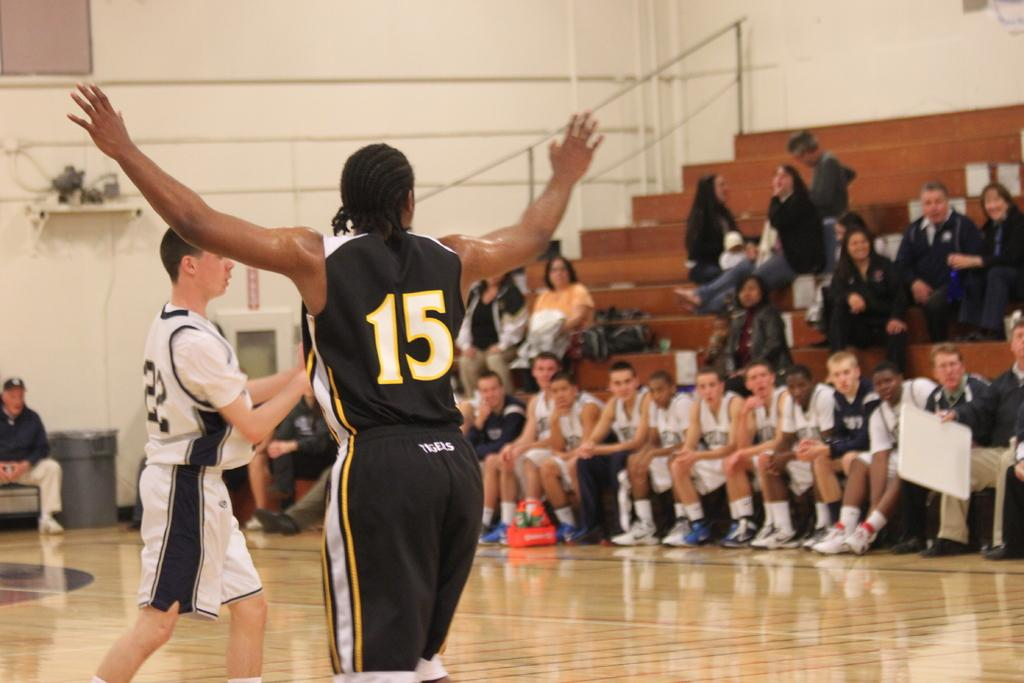What are the people in the center of the image doing? The people standing in the center of the image are likely engaged in some activity or conversation. What can be seen in the background of the image? In the background, there are people sitting on the stairs, and there is a wall. What is the surface beneath the people in the image? The bottom of the image contains a floor. What type of wheel can be seen in the image? There is no wheel present in the image. How are the people in the image rubbing against each other? The people in the image are not rubbing against each other; they are standing or sitting in various positions. 